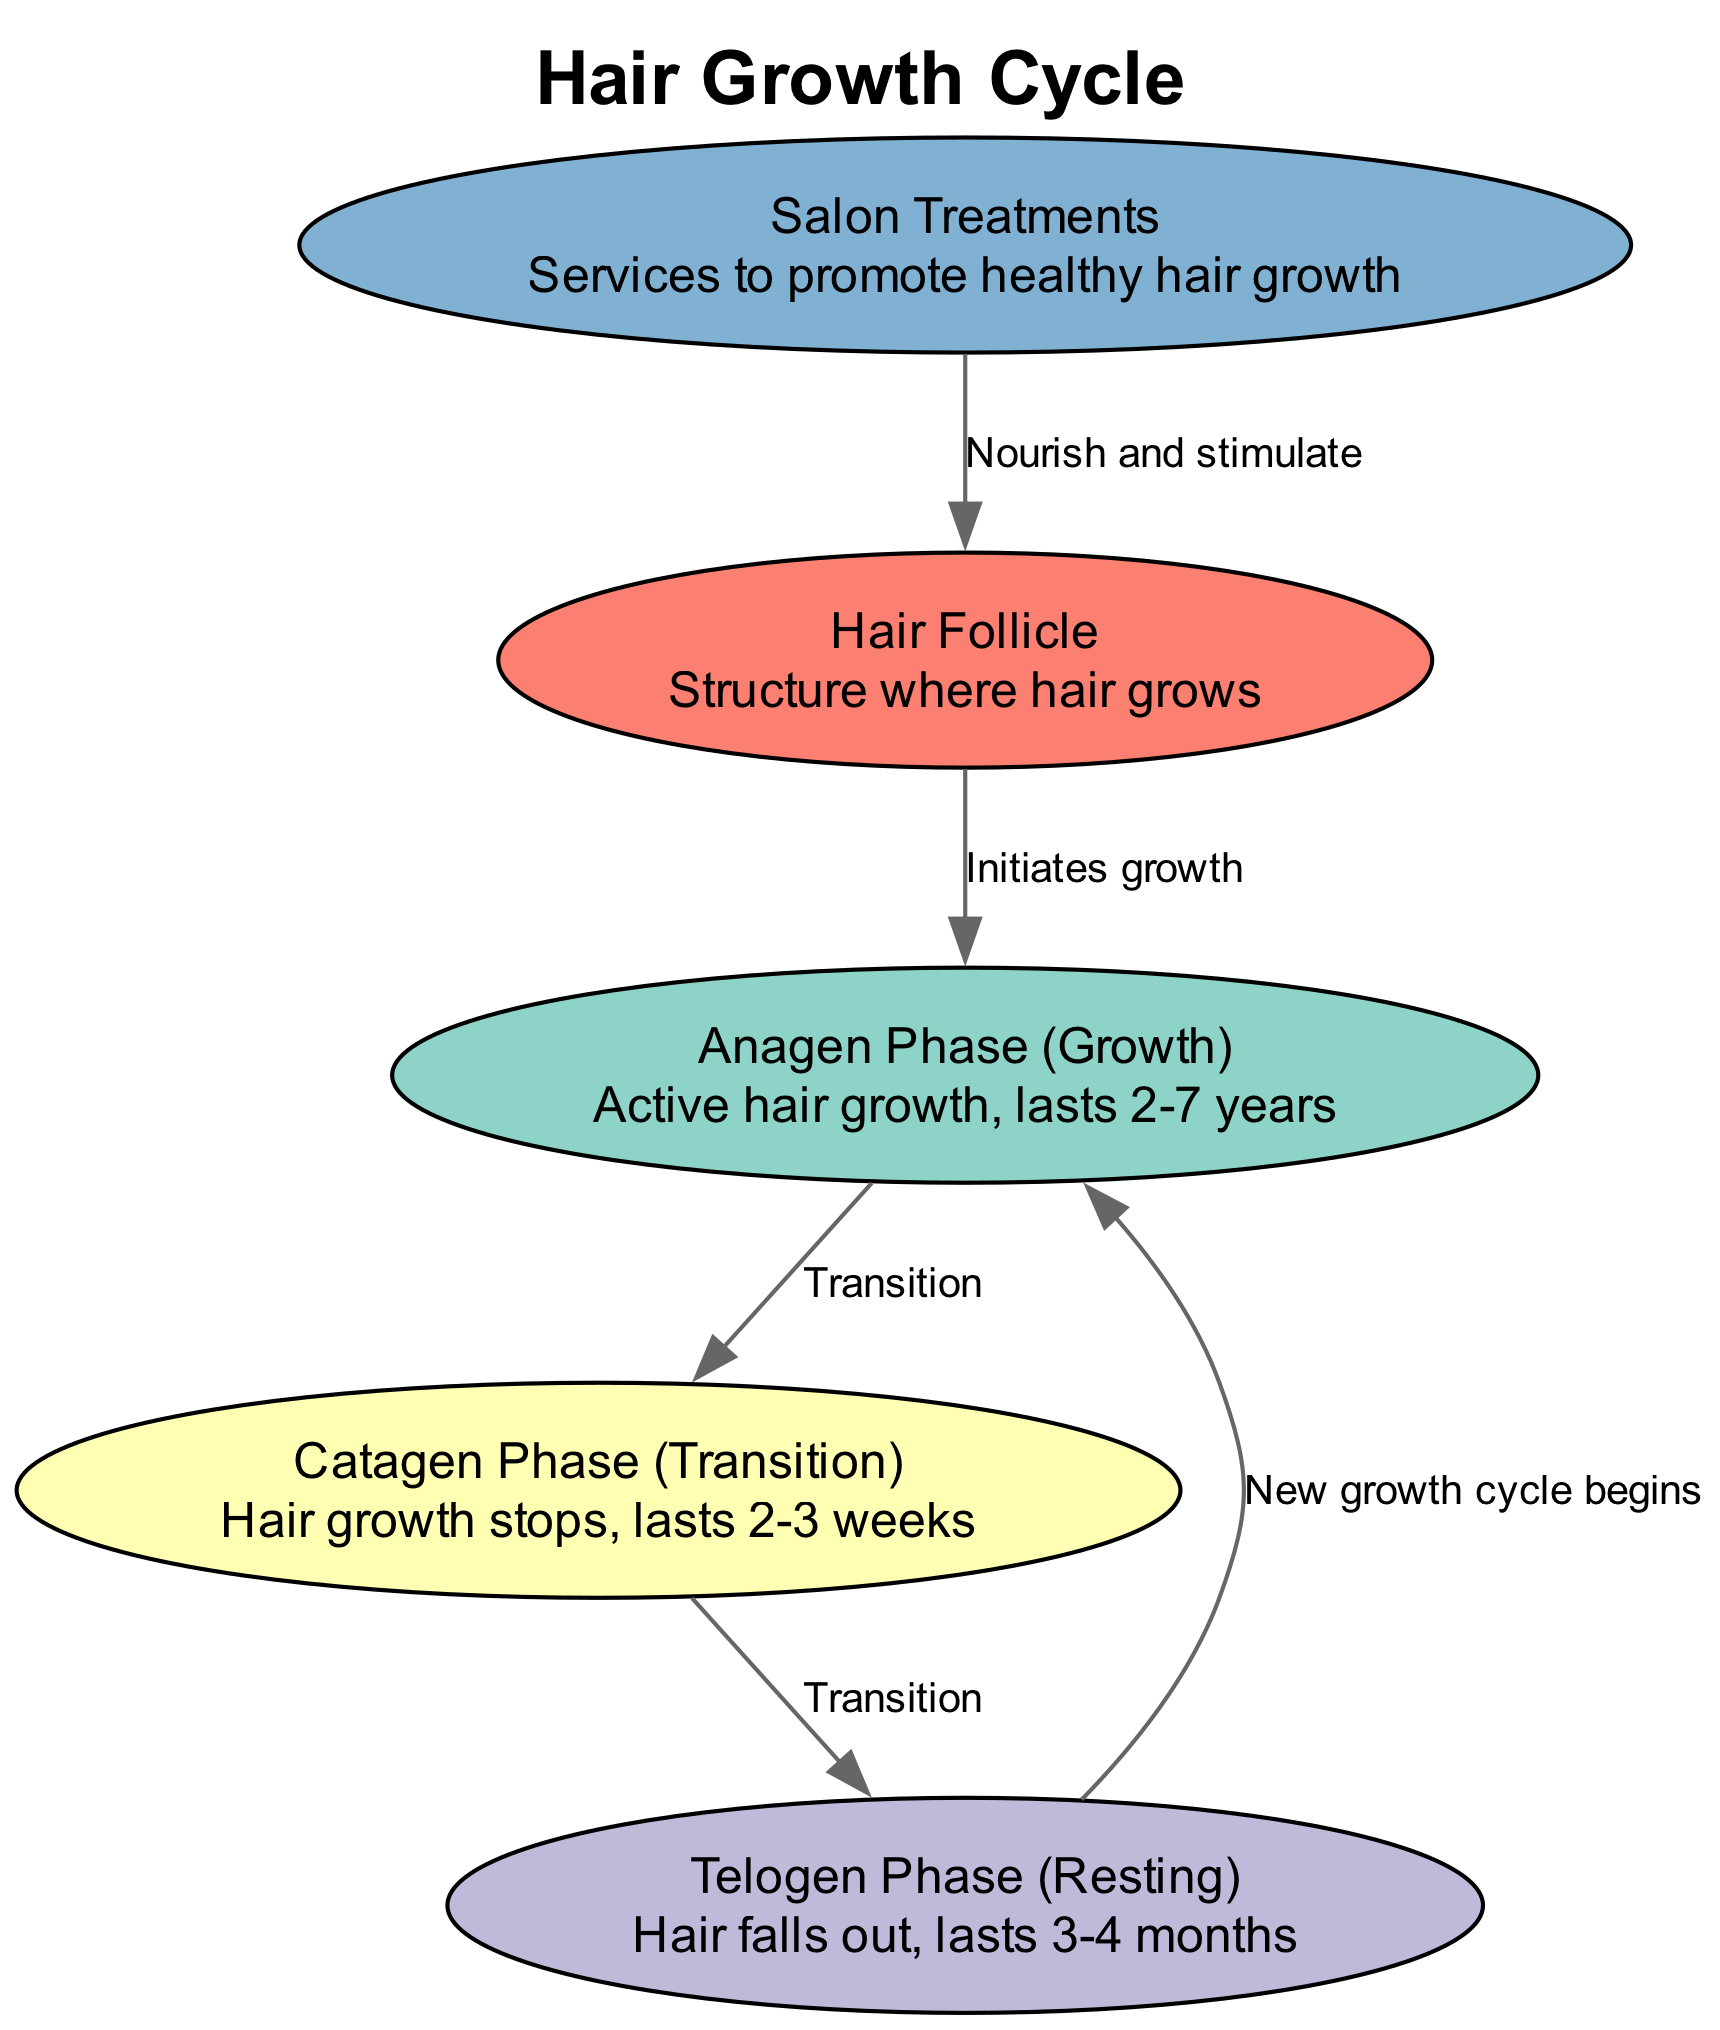What are the three phases of the hair growth cycle? The diagram lists three phases: Anagen, Catagen, and Telogen. These are identified as nodes in the diagram.
Answer: Anagen, Catagen, Telogen How long does the Anagen phase last? In the description for the Anagen phase, it states that this phase lasts 2-7 years. This information is directly from the node description in the diagram.
Answer: 2-7 years What is the main function of the hair follicle? The hair follicle is described in the diagram as the structure where hair grows, thus indicating its primary function.
Answer: Structure where hair grows What is the transition from Catagen to Telogen called? The edge between the Catagen and Telogen phases is labeled "Transition," indicating that this is the process through which hair moves from one phase to the next.
Answer: Transition How does the hair follicle relate to the Anagen phase? The diagram shows an edge from the follicle to the Anagen phase labeled "Initiates growth," indicating that hair follicle activity is responsible for starting the growth phase.
Answer: Initiates growth How many transitions occur in the hair growth cycle? By analyzing the edges, there are a total of three transitions: Anagen to Catagen, Catagen to Telogen, and Telogen back to Anagen, indicating a total of three distinct transition points.
Answer: Three What phase occurs after Telogen? According to the flow of the diagram, after the Telogen phase, the cycle returns to the Anagen phase, marking the beginning of a new growth cycle.
Answer: Anagen What role do salon treatments play in the hair growth cycle? The diagram notes that salon treatments nourish and stimulate the hair follicle, indicating their importance in promoting healthy hair growth within the cycle.
Answer: Nourish and stimulate 